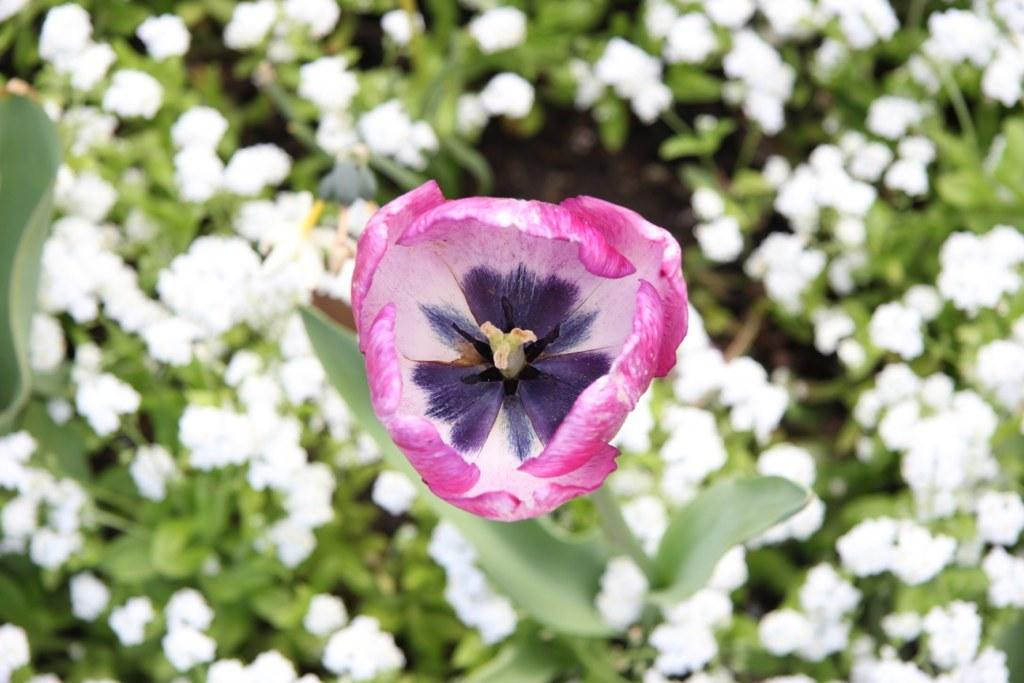What type of plants are present in the image? There are plants with flowers in the image. Can you describe the color of one of the flowers? There is a pink colored flower in the image. What can be seen on the left side of the image? There is an object on the left side of the image. Is there a trail of footprints leading to the plants in the image? There is no trail of footprints visible in the image. Can you provide an example of a railway station in the image? There is no railway station present in the image. 